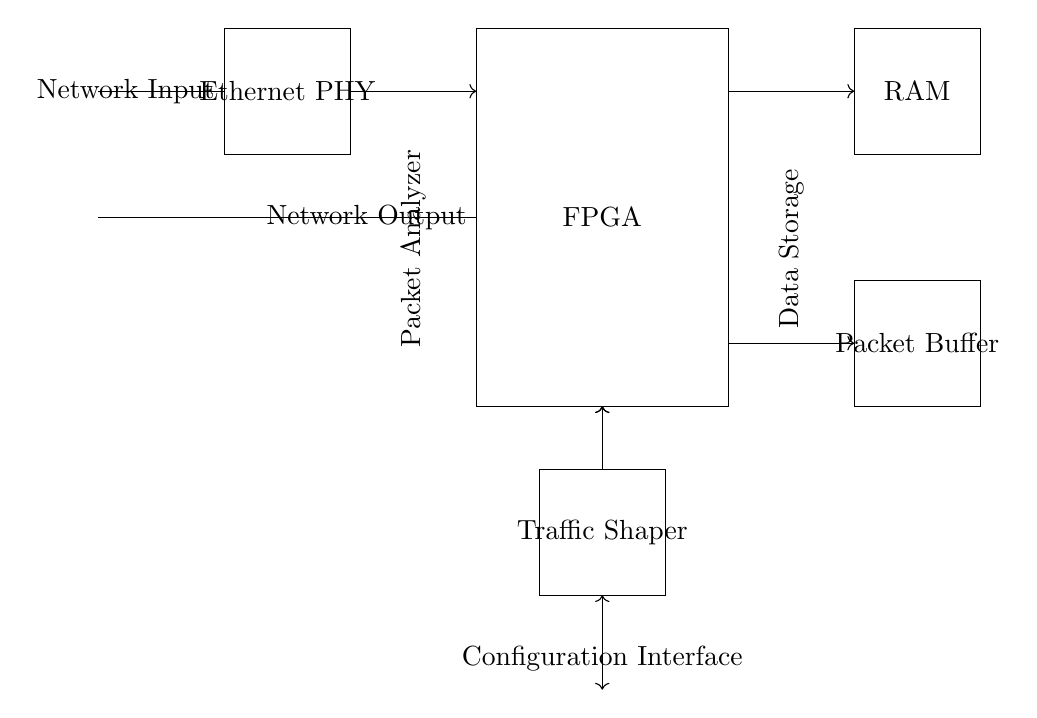What component is responsible for analyzing packets? The circuit diagram includes a labeled rectangular component denoting "Packet Analyzer", which is the specific part tasked with analyzing network packets.
Answer: Packet Analyzer What does the FPGA connect to on the left? The diagram shows that on the left side the FPGA connects to the Ethernet PHY, highlighted by an arrow indicating a direct connection between these two components.
Answer: Ethernet PHY How is the packet buffer involved in the data flow? The packet buffer is connected to the RAM and illustrates that it can receive data (from the FPGA) and store it temporarily, as indicated by the arrows showing data flow in and out to those components.
Answer: Temporary data storage What is the primary function of the Traffic Shaper? The Traffic Shaper is specifically identified in the diagram as a component, suggesting its role in regulating data transmission rates by controlling the flow and queuing of packets as they pass through.
Answer: Regulate data transmission How many components are primarily involved in this circuit? The circuit diagram lists several components: FPGA, Ethernet PHY, RAM, Packet Buffer, and Traffic Shaper, totaling five major components that serve critical roles in the overall design.
Answer: Five components What might the configuration interface allow a user to do? The Configuration Interface is indicated in the circuit and typically provides users with the capability to set parameters, manage configurations, and adjust settings relevant to the FPGA and related components, enhancing their functioning.
Answer: Set parameters 